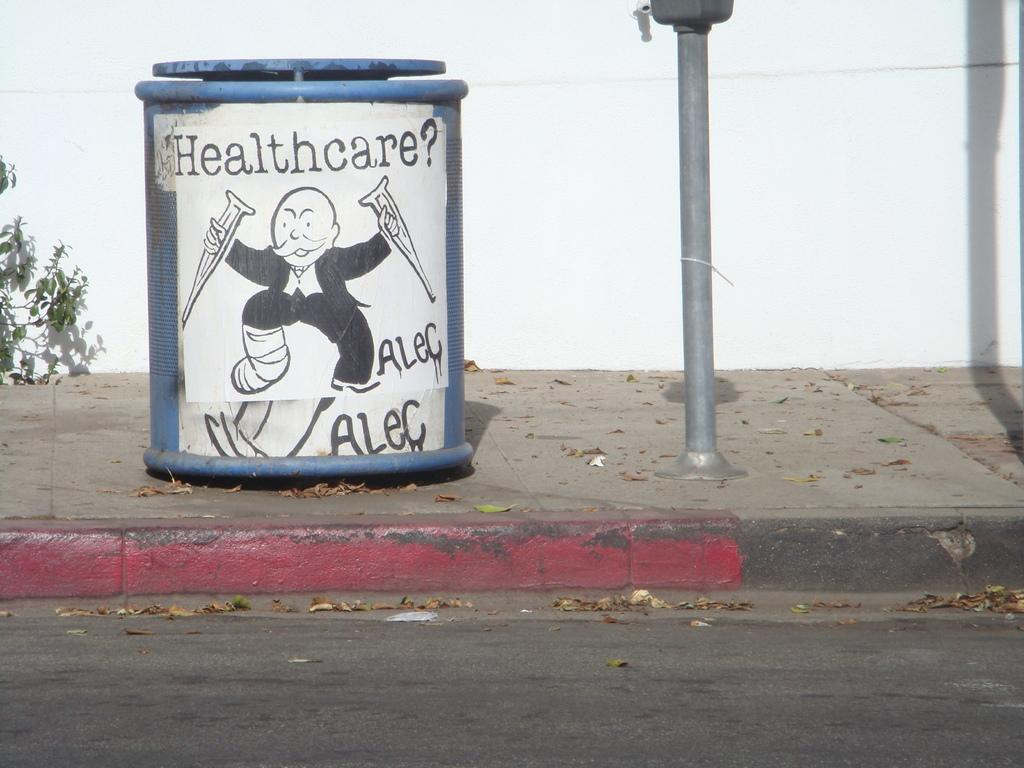Provide a one-sentence caption for the provided image. A blue container with Healthcare? on the front of the label. 